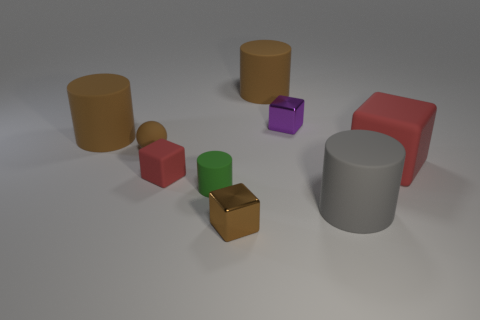Are there the same number of big red matte cubes that are on the left side of the big gray object and big cyan matte spheres?
Make the answer very short. Yes. What number of other things are the same color as the large matte block?
Provide a short and direct response. 1. There is a object that is in front of the green thing and right of the purple metal object; what is its color?
Offer a terse response. Gray. What is the size of the brown cylinder behind the big brown matte thing on the left side of the brown rubber thing that is right of the green object?
Keep it short and to the point. Large. What number of objects are cubes that are to the left of the tiny brown cube or large brown objects left of the small brown metal object?
Keep it short and to the point. 2. What is the shape of the small purple object?
Offer a terse response. Cube. What number of other objects are the same material as the small red object?
Ensure brevity in your answer.  6. The gray thing that is the same shape as the green thing is what size?
Give a very brief answer. Large. There is a tiny brown cube on the left side of the block that is behind the big brown cylinder on the left side of the rubber ball; what is it made of?
Your response must be concise. Metal. Are any small cyan metal blocks visible?
Keep it short and to the point. No. 